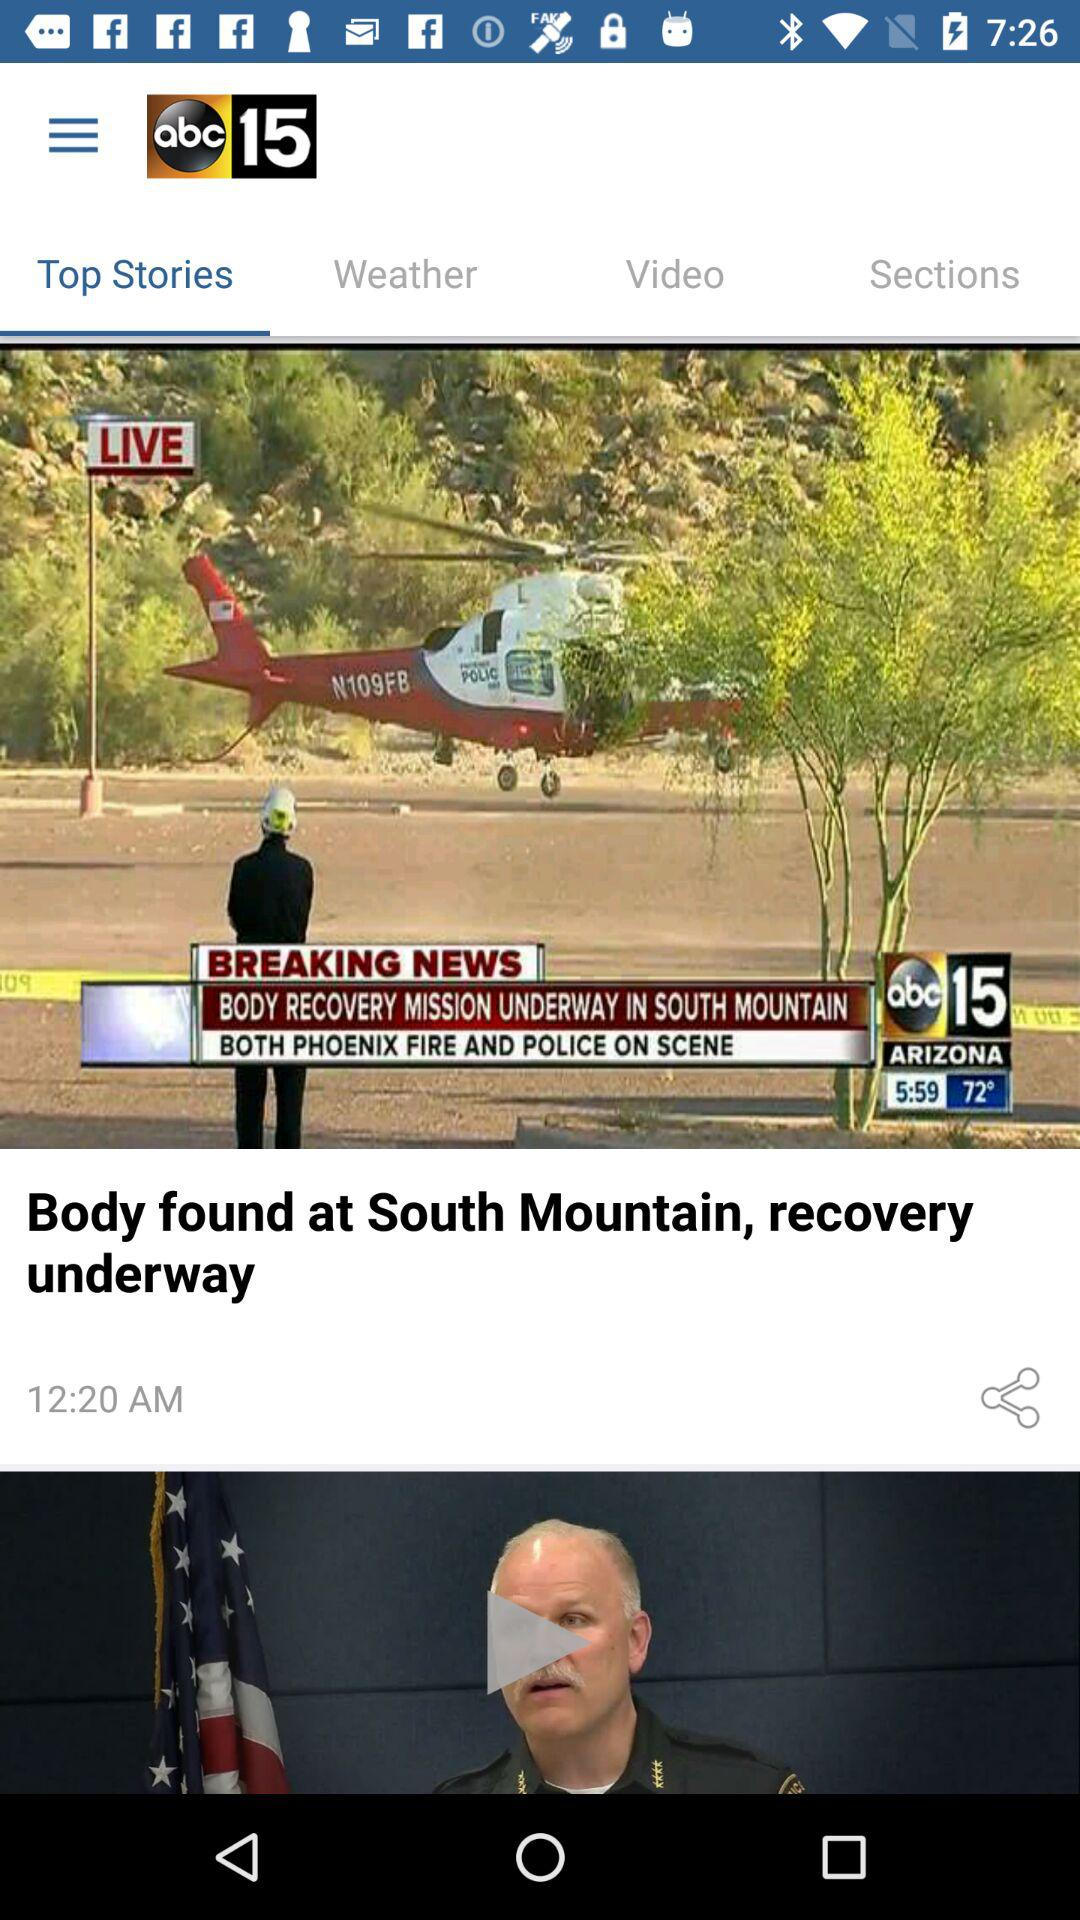At what time was the news "Body found at South Mountain, recovery underway" posted? The news "Body found at South Mountain, recovery underway" was posted at 12:20 AM. 